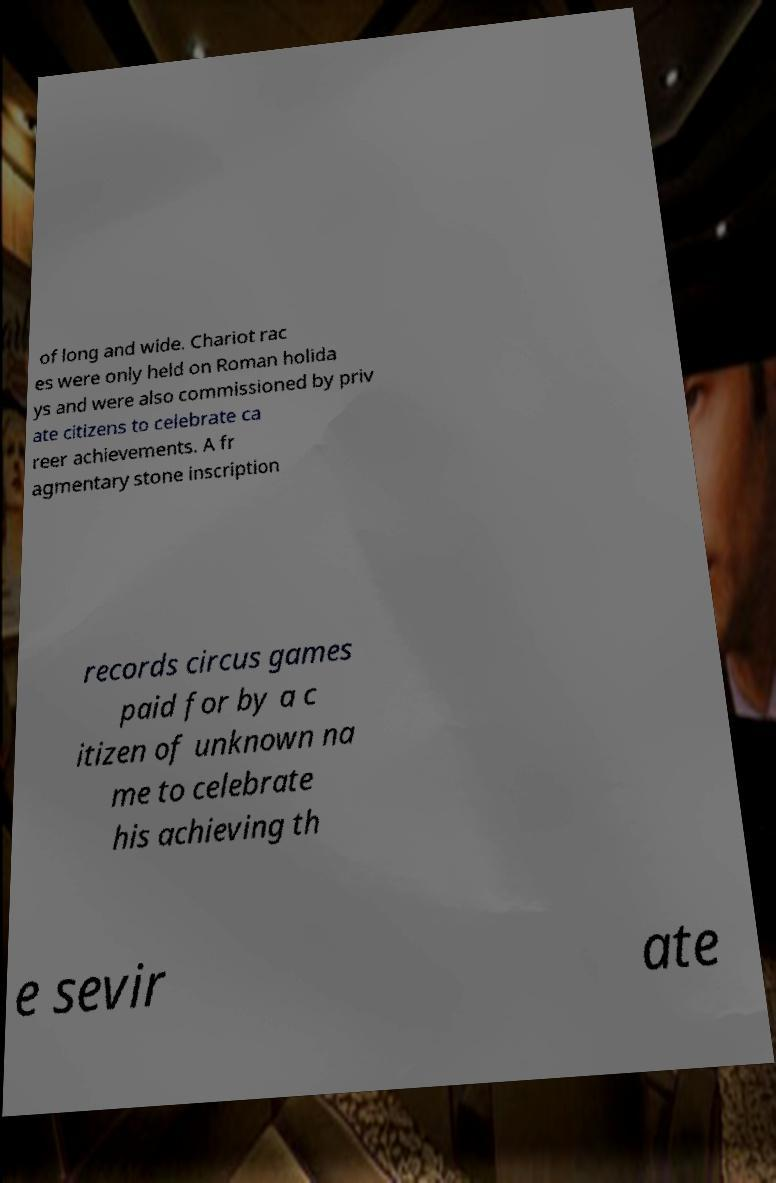There's text embedded in this image that I need extracted. Can you transcribe it verbatim? of long and wide. Chariot rac es were only held on Roman holida ys and were also commissioned by priv ate citizens to celebrate ca reer achievements. A fr agmentary stone inscription records circus games paid for by a c itizen of unknown na me to celebrate his achieving th e sevir ate 